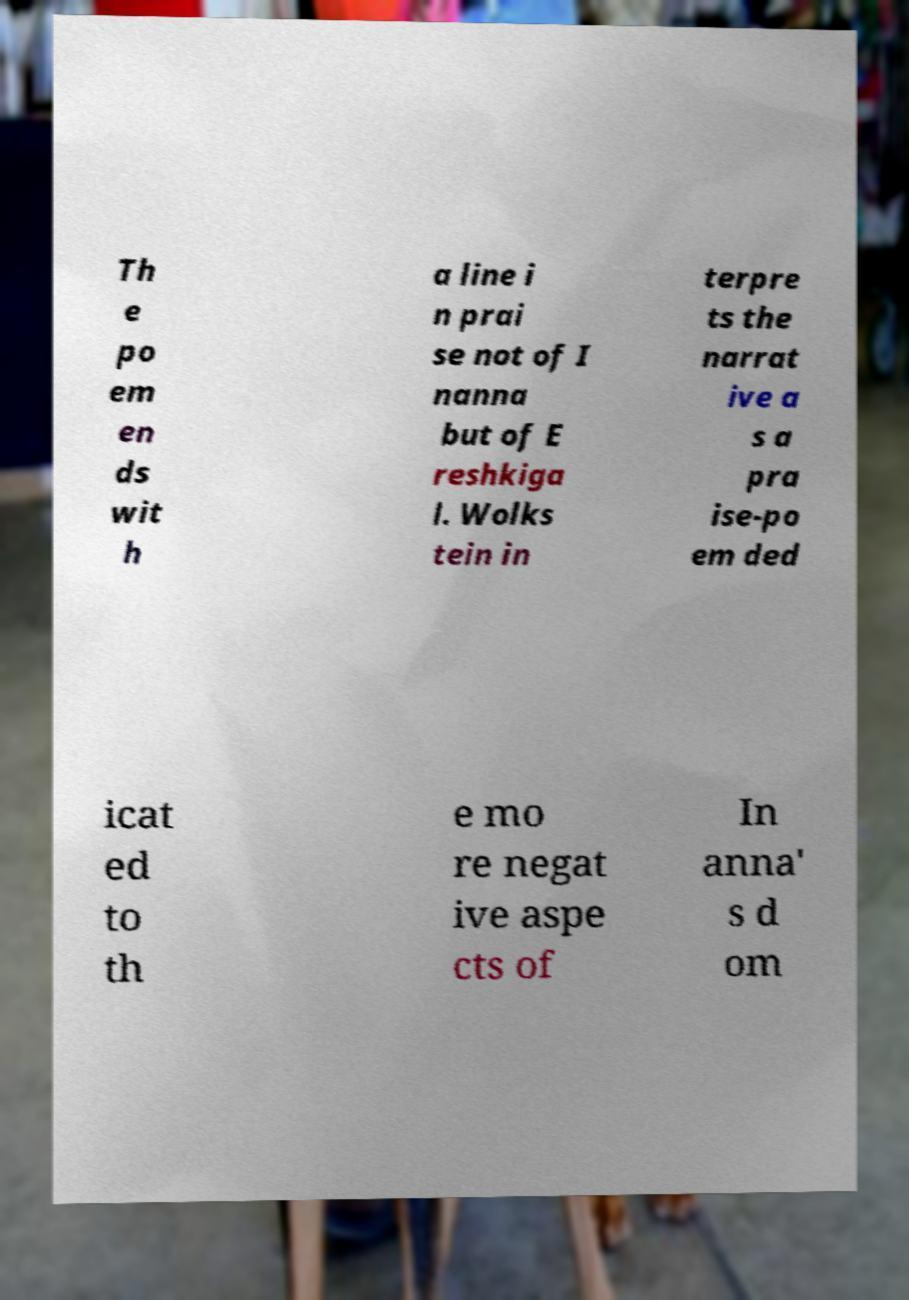I need the written content from this picture converted into text. Can you do that? Th e po em en ds wit h a line i n prai se not of I nanna but of E reshkiga l. Wolks tein in terpre ts the narrat ive a s a pra ise-po em ded icat ed to th e mo re negat ive aspe cts of In anna' s d om 